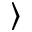Convert formula to latex. <formula><loc_0><loc_0><loc_500><loc_500>\rangle</formula> 